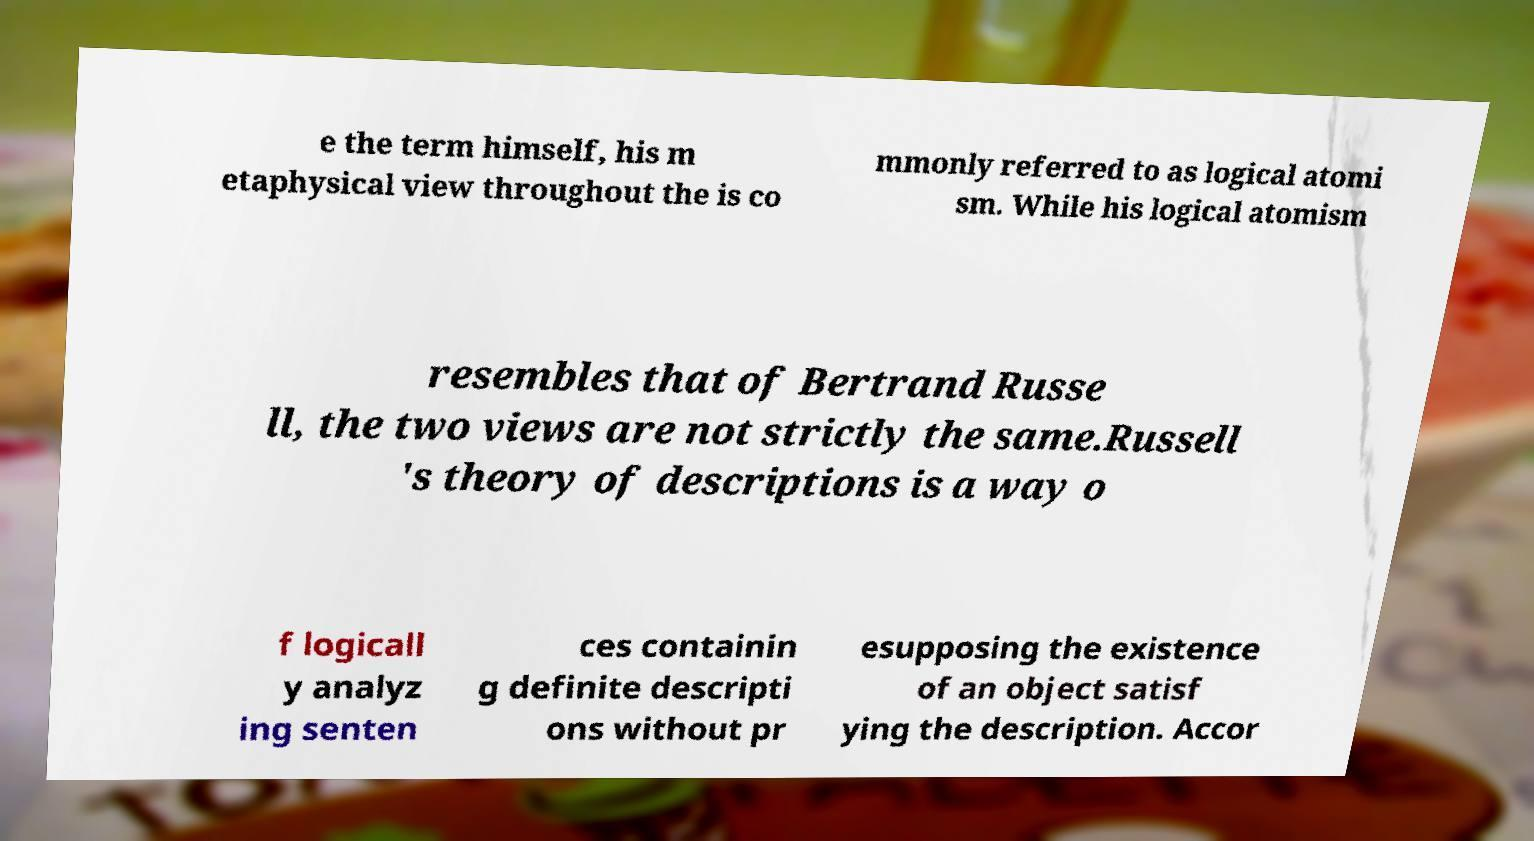Could you extract and type out the text from this image? e the term himself, his m etaphysical view throughout the is co mmonly referred to as logical atomi sm. While his logical atomism resembles that of Bertrand Russe ll, the two views are not strictly the same.Russell 's theory of descriptions is a way o f logicall y analyz ing senten ces containin g definite descripti ons without pr esupposing the existence of an object satisf ying the description. Accor 